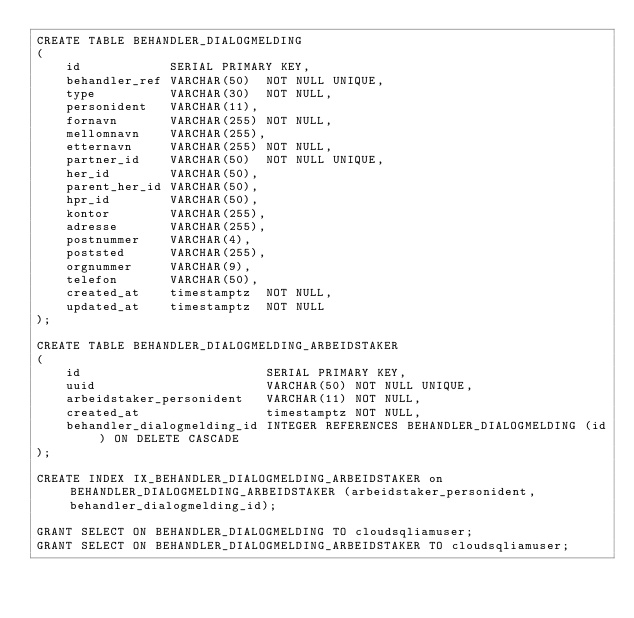Convert code to text. <code><loc_0><loc_0><loc_500><loc_500><_SQL_>CREATE TABLE BEHANDLER_DIALOGMELDING
(
    id            SERIAL PRIMARY KEY,
    behandler_ref VARCHAR(50)  NOT NULL UNIQUE,
    type          VARCHAR(30)  NOT NULL,
    personident   VARCHAR(11),
    fornavn       VARCHAR(255) NOT NULL,
    mellomnavn    VARCHAR(255),
    etternavn     VARCHAR(255) NOT NULL,
    partner_id    VARCHAR(50)  NOT NULL UNIQUE,
    her_id        VARCHAR(50),
    parent_her_id VARCHAR(50),
    hpr_id        VARCHAR(50),
    kontor        VARCHAR(255),
    adresse       VARCHAR(255),
    postnummer    VARCHAR(4),
    poststed      VARCHAR(255),
    orgnummer     VARCHAR(9),
    telefon       VARCHAR(50),
    created_at    timestamptz  NOT NULL,
    updated_at    timestamptz  NOT NULL
);

CREATE TABLE BEHANDLER_DIALOGMELDING_ARBEIDSTAKER
(
    id                         SERIAL PRIMARY KEY,
    uuid                       VARCHAR(50) NOT NULL UNIQUE,
    arbeidstaker_personident   VARCHAR(11) NOT NULL,
    created_at                 timestamptz NOT NULL,
    behandler_dialogmelding_id INTEGER REFERENCES BEHANDLER_DIALOGMELDING (id) ON DELETE CASCADE
);

CREATE INDEX IX_BEHANDLER_DIALOGMELDING_ARBEIDSTAKER on BEHANDLER_DIALOGMELDING_ARBEIDSTAKER (arbeidstaker_personident, behandler_dialogmelding_id);

GRANT SELECT ON BEHANDLER_DIALOGMELDING TO cloudsqliamuser;
GRANT SELECT ON BEHANDLER_DIALOGMELDING_ARBEIDSTAKER TO cloudsqliamuser;
</code> 